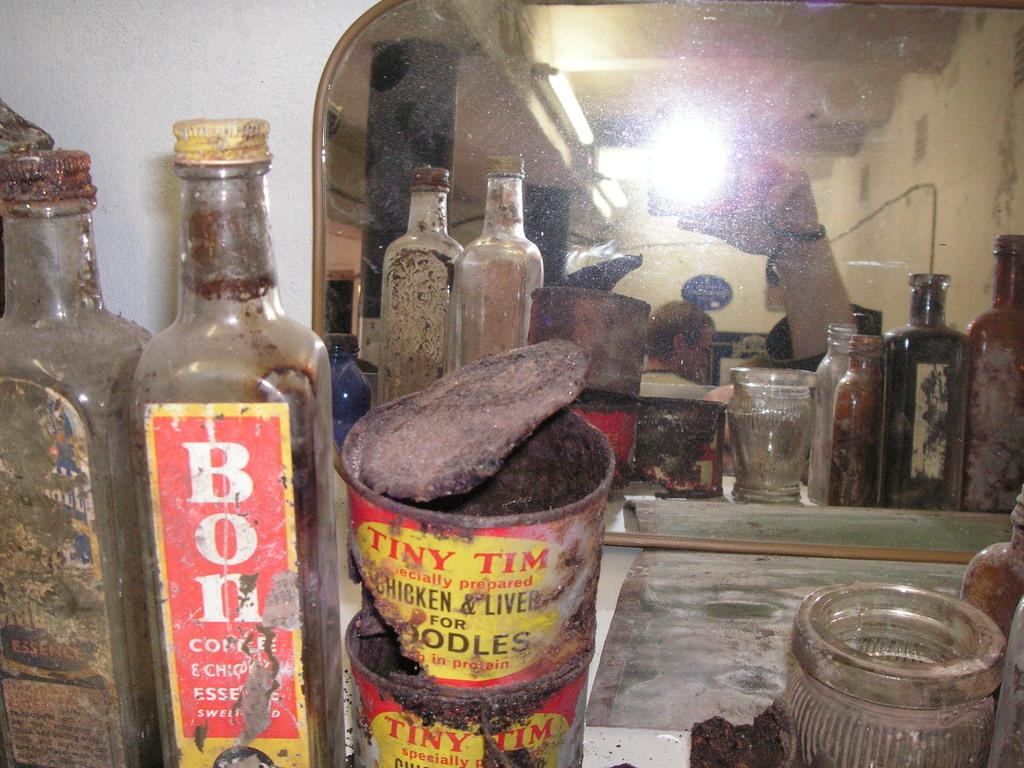<image>
Provide a brief description of the given image. An old collection of jars and tins including a tin of chicken liver. 